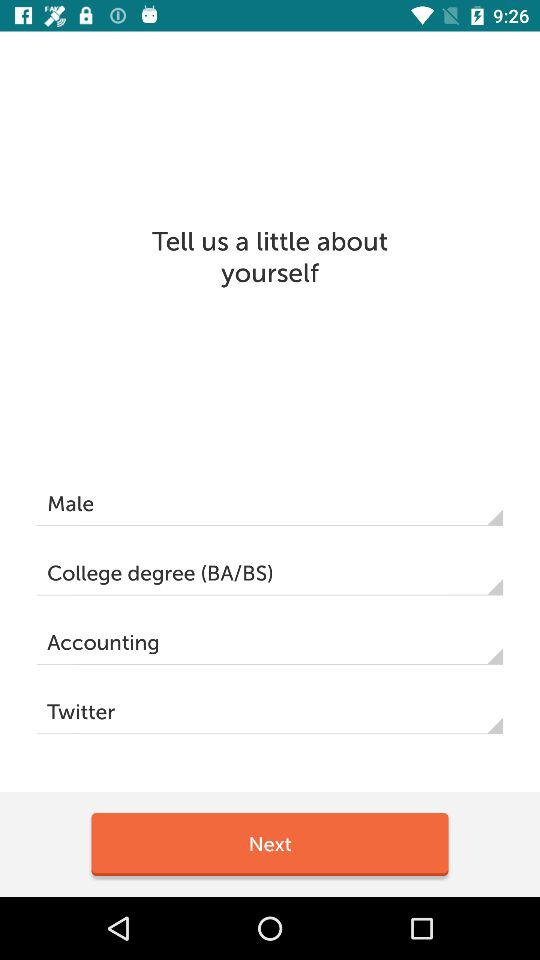What is the gender? The gender is male. 